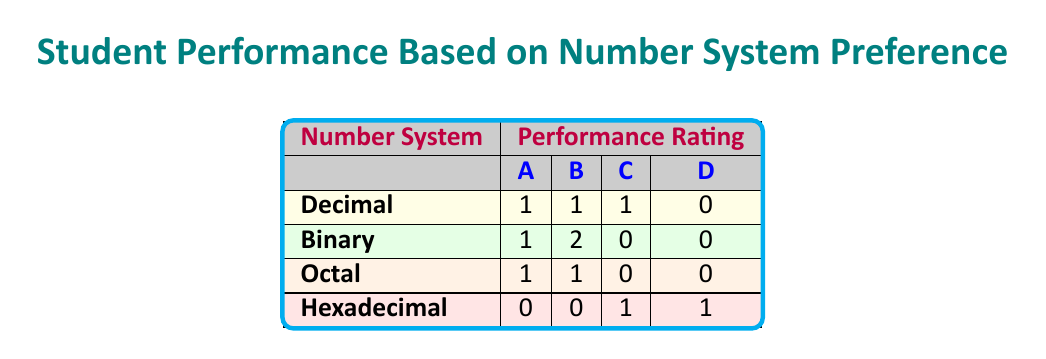What is the performance rating for students who prefer the Decimal number system? According to the table, there are three students who prefer Decimal, with performance ratings of A, B, and C. Hence, the performance ratings for students who prefer Decimal are A, B, and C.
Answer: A, B, C How many students received a performance rating of A? From the table, there are three students who received a performance rating of A: Alice Johnson (Decimal), Frank Wilson (Binary), and Catherine Lee (Octal). Therefore, the total count is 3.
Answer: 3 What is the total number of students who prefer the Hexadecimal number system? Referring to the table, there are two students who prefer Hexadecimal, namely David Brown and Henry Clark. Thus, the total number of students in this category is 2.
Answer: 2 Is there any student who received a performance rating of D? Checking the table, only Henry Clark, who prefers Hexadecimal, has a performance rating of D. This confirms that yes, there is at least one student with this rating.
Answer: Yes What is the difference in the count of students with performance rating B between Binary and Octal number systems? Referring to the table, the count of students with a B rating in Binary is 2 (Brian Smith and Jack Miller), and in Octal, it is 1 (Grace White). The difference, therefore, is 2 - 1 = 1.
Answer: 1 What is the average performance rating of students who prefer the Binary number system? In the table, the Binary system has three ratings: A, B, and B. For average calculation, assign numeric values: A=4, B=3. The average is (4 + 3 + 3) / 3 = 10 / 3 ≈ 3.33, which corresponds to a rating between B and A.
Answer: B/A Which number system has the least performing student, and what is their rating? Observing the table, the Hexadecimal system has a student (Henry Clark) with a performance rating of D, which is the lowest rating among all numbers systems. Thus, Hexadecimal has the least performing student.
Answer: Hexadecimal, D How many students rated below a C in performance? Looking at the ratings, only David Brown (Hexadecimal, C) and Henry Clark (Hexadecimal, D) are below C, hence the count is 2 students rated below C.
Answer: 2 In which number system do the majority of students have a performance rating of B? The Binary number system has the highest count, with 2 students rated B (Brian Smith and Jack Miller), compared to others. Thus, Binary has the majority rated B.
Answer: Binary 